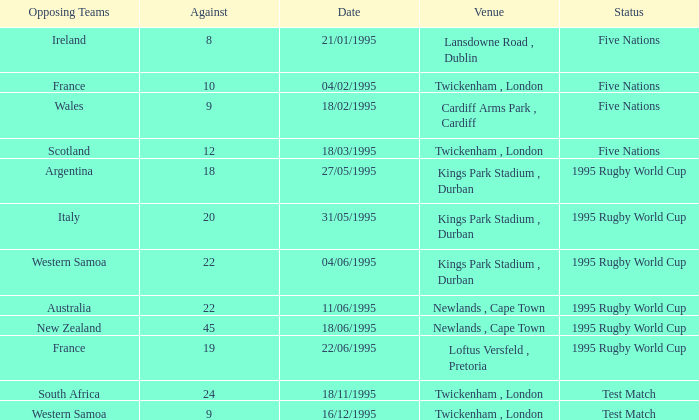What's the total against for opposing team scotland at twickenham, london venue with a status of five nations? 1.0. 